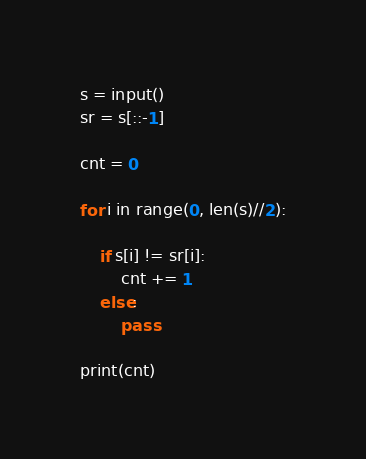<code> <loc_0><loc_0><loc_500><loc_500><_Python_>s = input()
sr = s[::-1]

cnt = 0

for i in range(0, len(s)//2):

    if s[i] != sr[i]:
        cnt += 1
    else:
        pass

print(cnt)
</code> 